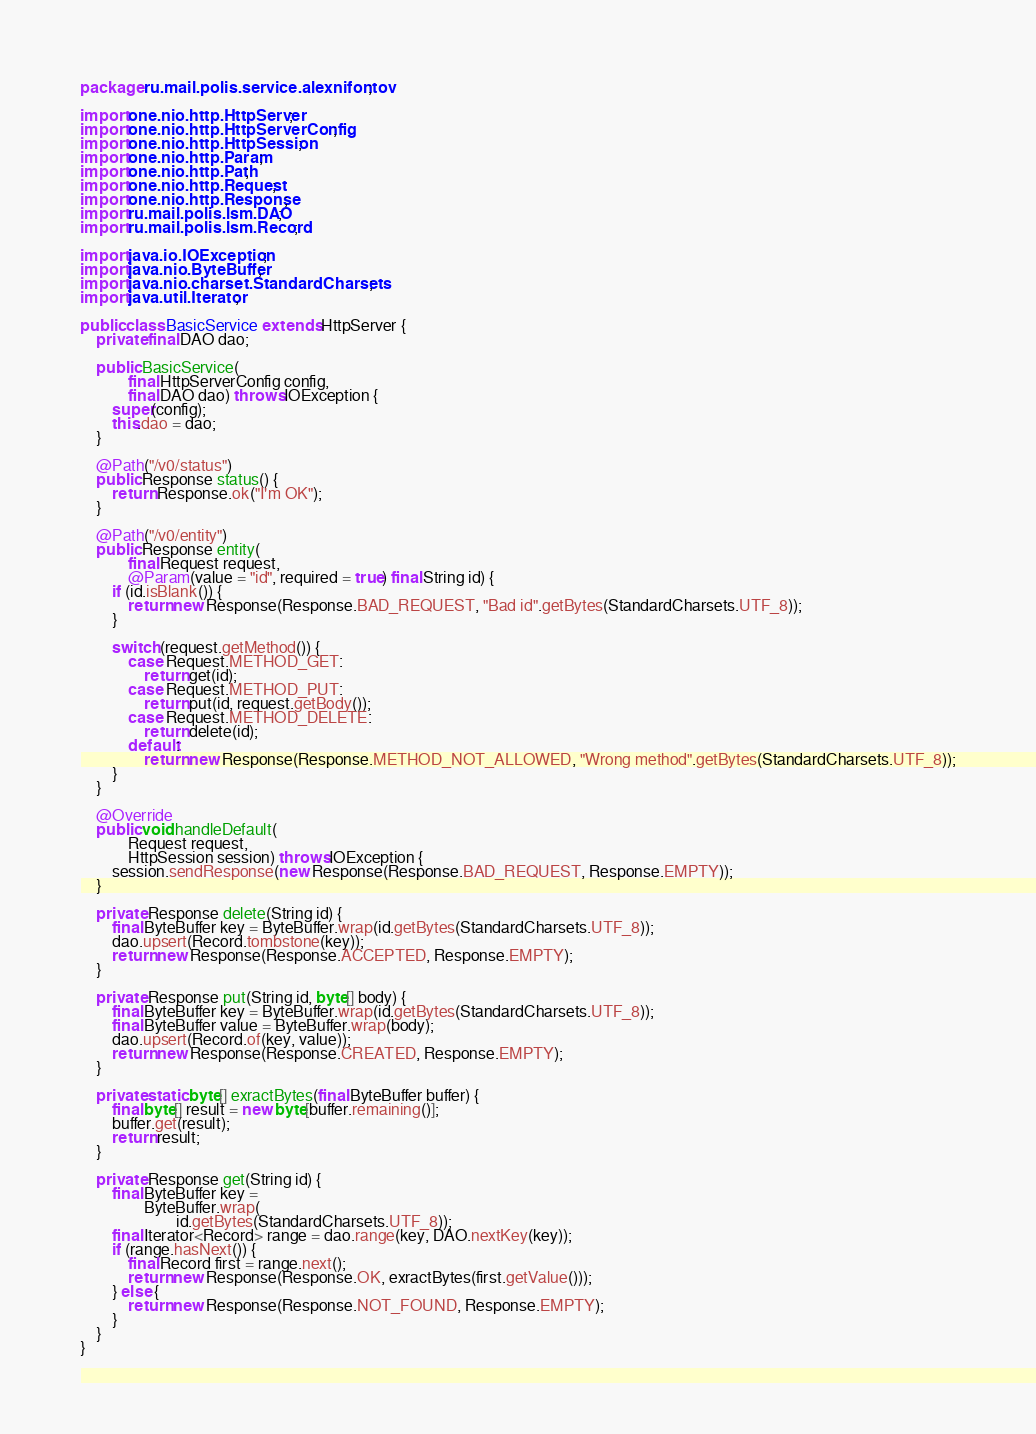<code> <loc_0><loc_0><loc_500><loc_500><_Java_>package ru.mail.polis.service.alexnifontov;

import one.nio.http.HttpServer;
import one.nio.http.HttpServerConfig;
import one.nio.http.HttpSession;
import one.nio.http.Param;
import one.nio.http.Path;
import one.nio.http.Request;
import one.nio.http.Response;
import ru.mail.polis.lsm.DAO;
import ru.mail.polis.lsm.Record;

import java.io.IOException;
import java.nio.ByteBuffer;
import java.nio.charset.StandardCharsets;
import java.util.Iterator;

public class BasicService extends HttpServer {
    private final DAO dao;

    public BasicService(
            final HttpServerConfig config,
            final DAO dao) throws IOException {
        super(config);
        this.dao = dao;
    }

    @Path("/v0/status")
    public Response status() {
        return Response.ok("I'm OK");
    }

    @Path("/v0/entity")
    public Response entity(
            final Request request,
            @Param(value = "id", required = true) final String id) {
        if (id.isBlank()) {
            return new Response(Response.BAD_REQUEST, "Bad id".getBytes(StandardCharsets.UTF_8));
        }

        switch (request.getMethod()) {
            case Request.METHOD_GET:
                return get(id);
            case Request.METHOD_PUT:
                return put(id, request.getBody());
            case Request.METHOD_DELETE:
                return delete(id);
            default:
                return new Response(Response.METHOD_NOT_ALLOWED, "Wrong method".getBytes(StandardCharsets.UTF_8));
        }
    }

    @Override
    public void handleDefault(
            Request request,
            HttpSession session) throws IOException {
        session.sendResponse(new Response(Response.BAD_REQUEST, Response.EMPTY));
    }

    private Response delete(String id) {
        final ByteBuffer key = ByteBuffer.wrap(id.getBytes(StandardCharsets.UTF_8));
        dao.upsert(Record.tombstone(key));
        return new Response(Response.ACCEPTED, Response.EMPTY);
    }

    private Response put(String id, byte[] body) {
        final ByteBuffer key = ByteBuffer.wrap(id.getBytes(StandardCharsets.UTF_8));
        final ByteBuffer value = ByteBuffer.wrap(body);
        dao.upsert(Record.of(key, value));
        return new Response(Response.CREATED, Response.EMPTY);
    }

    private static byte[] exractBytes(final ByteBuffer buffer) {
        final byte[] result = new byte[buffer.remaining()];
        buffer.get(result);
        return result;
    }

    private Response get(String id) {
        final ByteBuffer key =
                ByteBuffer.wrap(
                        id.getBytes(StandardCharsets.UTF_8));
        final Iterator<Record> range = dao.range(key, DAO.nextKey(key));
        if (range.hasNext()) {
            final Record first = range.next();
            return new Response(Response.OK, exractBytes(first.getValue()));
        } else {
            return new Response(Response.NOT_FOUND, Response.EMPTY);
        }
    }
}
</code> 